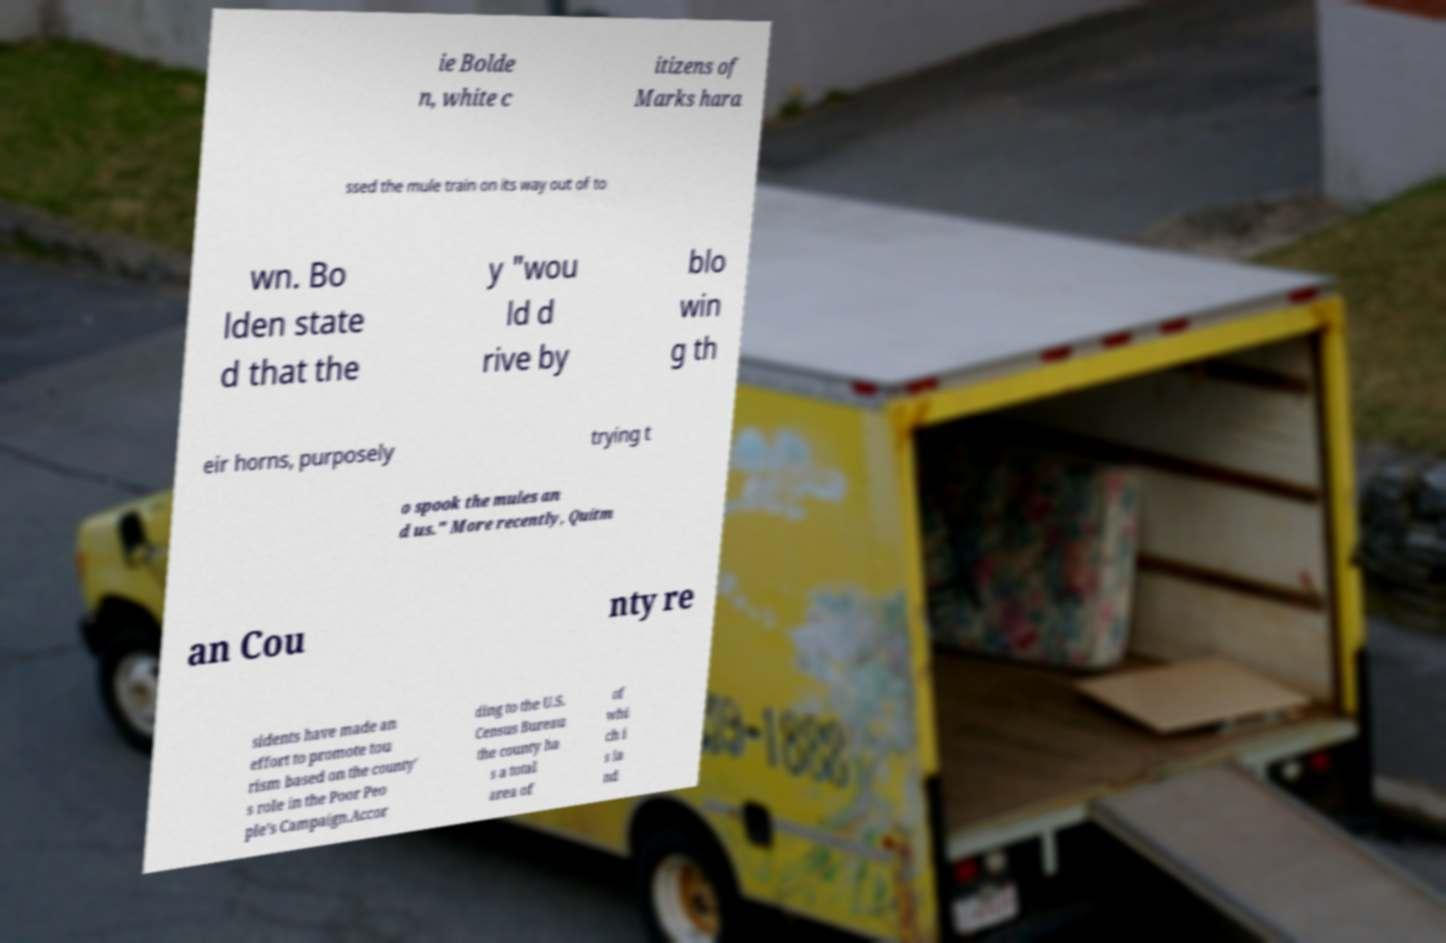What messages or text are displayed in this image? I need them in a readable, typed format. ie Bolde n, white c itizens of Marks hara ssed the mule train on its way out of to wn. Bo lden state d that the y "wou ld d rive by blo win g th eir horns, purposely trying t o spook the mules an d us." More recently, Quitm an Cou nty re sidents have made an effort to promote tou rism based on the county' s role in the Poor Peo ple's Campaign.Accor ding to the U.S. Census Bureau the county ha s a total area of of whi ch i s la nd 